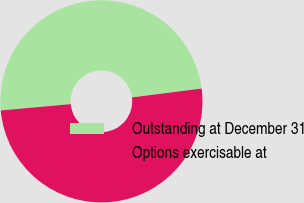Convert chart. <chart><loc_0><loc_0><loc_500><loc_500><pie_chart><fcel>Outstanding at December 31<fcel>Options exercisable at<nl><fcel>49.42%<fcel>50.58%<nl></chart> 